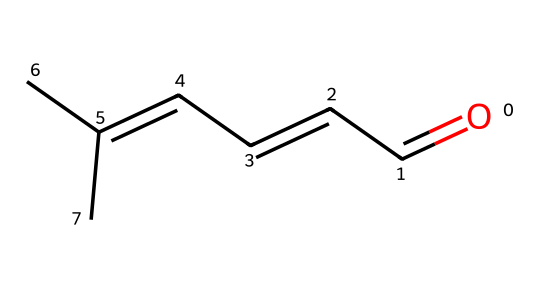What functional group is present in cinnamaldehyde? The chemical structure shows a carbonyl group (C=O) attached to a carbon atom; this indicates that it is an aldehyde, which is characterized by the presence of a carbonyl group at the end of the carbon chain.
Answer: aldehyde How many carbon atoms are in cinnamaldehyde? By analyzing the SMILES representation, there are a total of 9 carbon symbols represented in the structure, which indicates there are 9 carbon atoms.
Answer: nine What is the total number of hydrogen atoms in cinnamaldehyde? In the structure, by considering the typical valency of carbon and the connection to the carbonyl group, we deduce there are 8 hydrogen symbols counted, giving a total of 8 hydrogen atoms.
Answer: eight What type of isomerism can occur in cinnamaldehyde due to its structure? The presence of a double bond and different arrangements of atoms suggests the possibility of geometric (cis-trans) isomerism arising from the limited rotation around the double bond between the first and second carbon atoms.
Answer: geometric isomerism What type of reaction is cinnamaldehyde likely to undergo due to its aldehyde group? Aldehydes typically undergo oxidation reactions; thus, cinnamaldehyde can be oxidized to form a carboxylic acid, specifically cinnamic acid, due to the reactive carbonyl group.
Answer: oxidation How does the unsaturation in cinnamaldehyde affect its properties compared to saturated aldehydes? The presence of a double bond in the structure contributes to unsaturation, which can increase reactivity and alter boiling points compared to saturated aldehydes that lack double bonds.
Answer: increased reactivity 